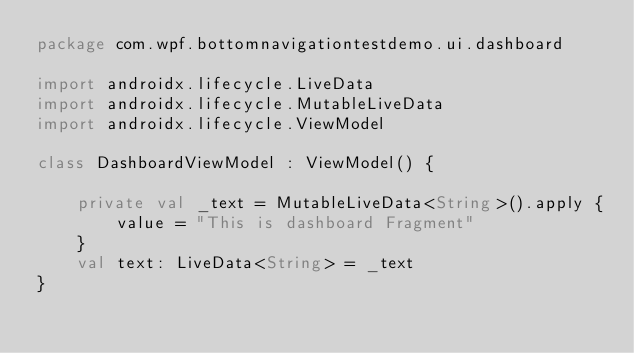<code> <loc_0><loc_0><loc_500><loc_500><_Kotlin_>package com.wpf.bottomnavigationtestdemo.ui.dashboard

import androidx.lifecycle.LiveData
import androidx.lifecycle.MutableLiveData
import androidx.lifecycle.ViewModel

class DashboardViewModel : ViewModel() {

    private val _text = MutableLiveData<String>().apply {
        value = "This is dashboard Fragment"
    }
    val text: LiveData<String> = _text
}</code> 